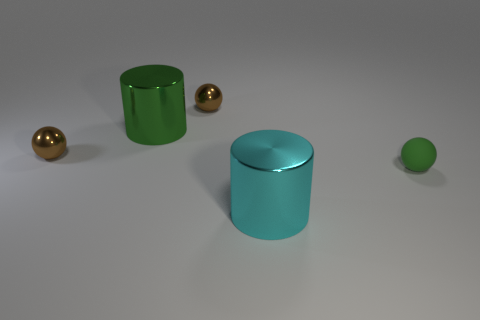There is a big cylinder right of the green metallic object; is there a brown ball that is in front of it? After reviewing the image, it appears that there is no brown ball in front of the big cylinder to the right of the green metallic object. Instead, there are two golden spheres, with one slightly to the right and in front of the green cylinder, and the other one further away to the left. The surface reflects the objects, hinting at a glossy or polished texture. 